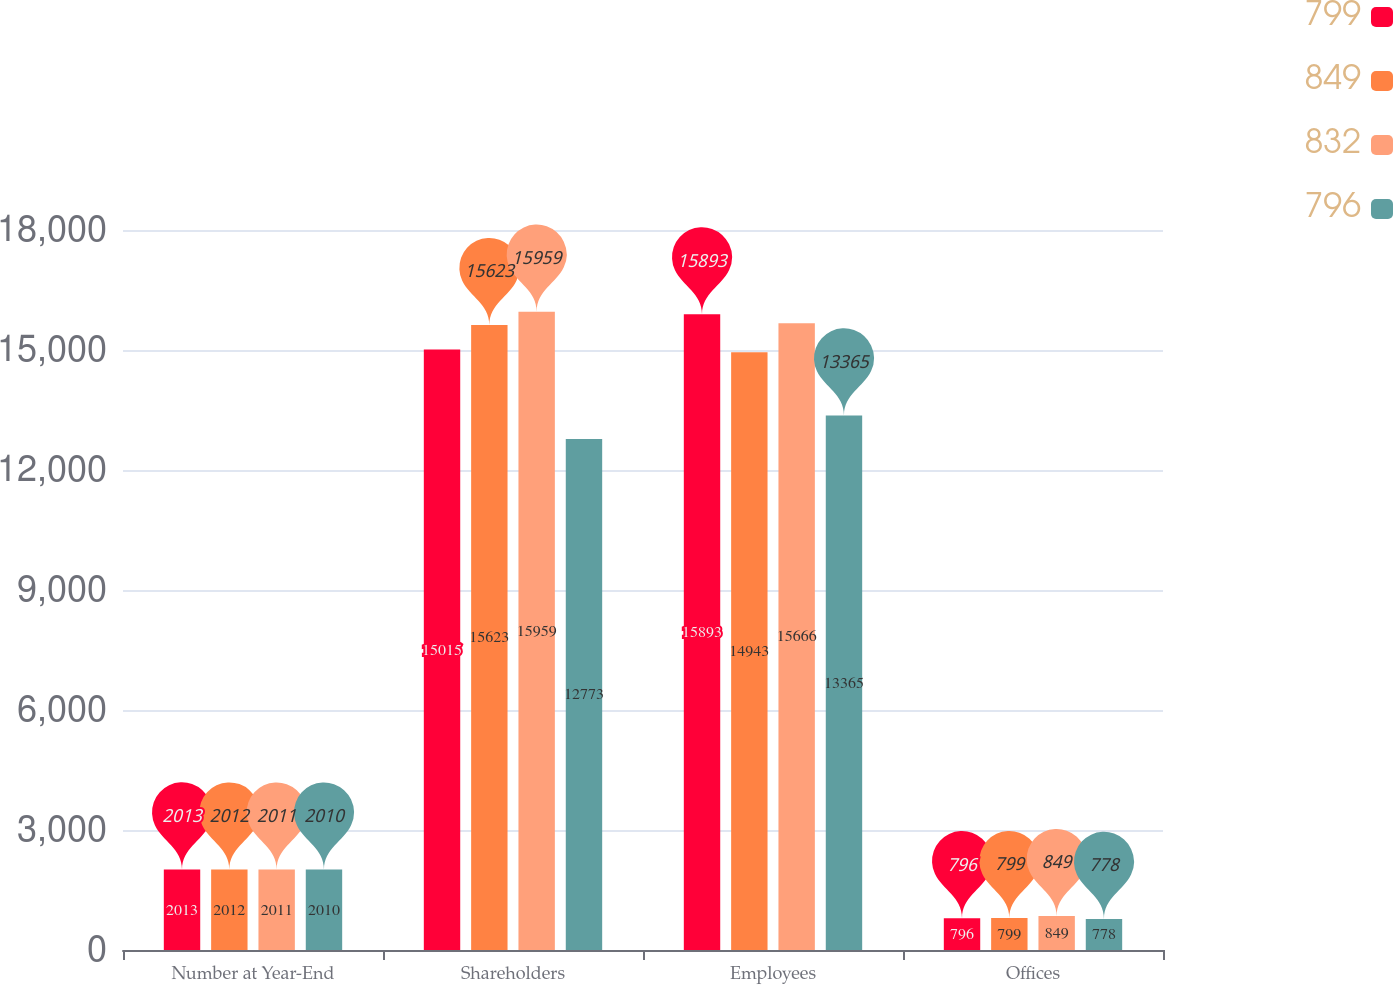Convert chart to OTSL. <chart><loc_0><loc_0><loc_500><loc_500><stacked_bar_chart><ecel><fcel>Number at Year-End<fcel>Shareholders<fcel>Employees<fcel>Offices<nl><fcel>799<fcel>2013<fcel>15015<fcel>15893<fcel>796<nl><fcel>849<fcel>2012<fcel>15623<fcel>14943<fcel>799<nl><fcel>832<fcel>2011<fcel>15959<fcel>15666<fcel>849<nl><fcel>796<fcel>2010<fcel>12773<fcel>13365<fcel>778<nl></chart> 